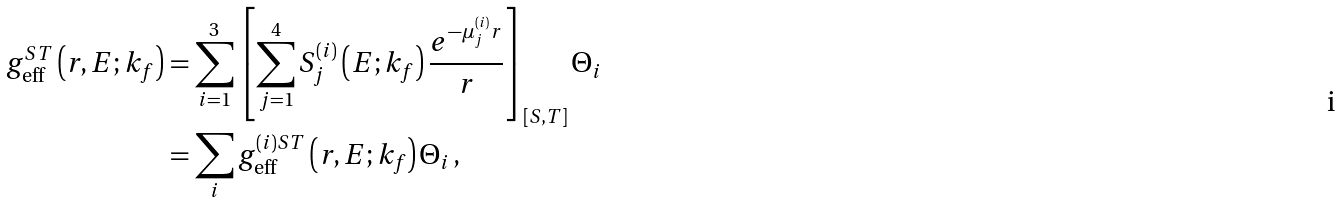<formula> <loc_0><loc_0><loc_500><loc_500>g ^ { S T } _ { \text {eff} } \left ( r , E ; k _ { f } \right ) & = \sum ^ { 3 } _ { i = 1 } \left [ \sum ^ { 4 } _ { j = 1 } S ^ { ( i ) } _ { j } \left ( E ; k _ { f } \right ) \frac { e ^ { - \mu ^ { ( i ) } _ { j } r } } { r } \right ] _ { \left [ S , T \right ] } \Theta _ { i } \\ & = \sum _ { i } g ^ { ( i ) S T } _ { \text {eff} } \left ( r , E ; k _ { f } \right ) \Theta _ { i } \, ,</formula> 